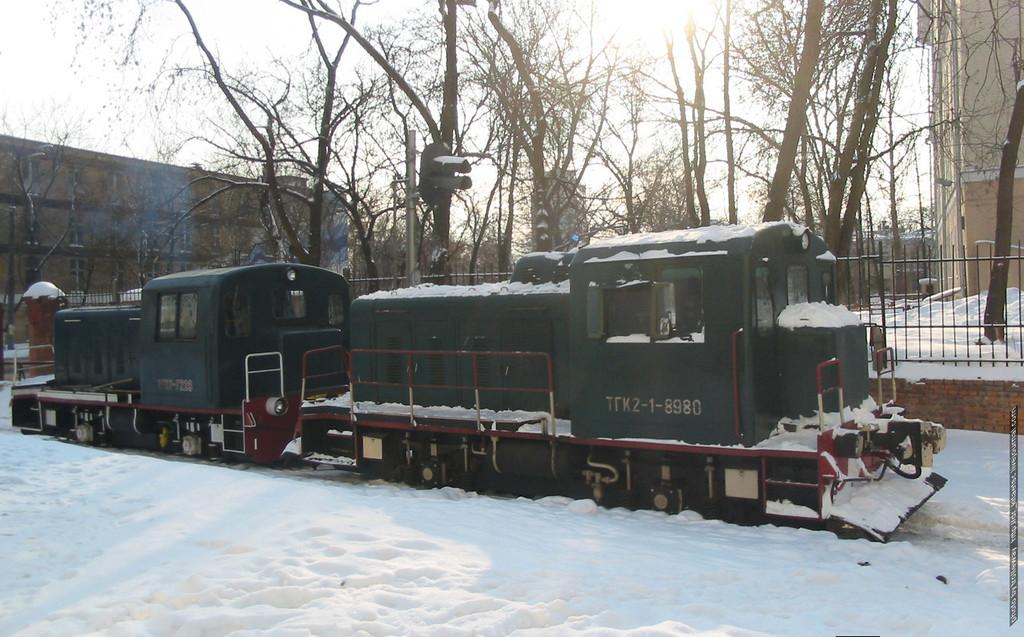What is the main feature of the landscape in the image? There is snow in the image. What mode of transportation can be seen in the image? There is a train in the image. What can be seen in the background of the image? There is a railing, many trees, buildings, and the sky visible in the background of the image. What type of hole can be seen in the image? There is no hole present in the image. What invention is being used by the train in the image? The image does not provide information about any specific invention being used by the train. 